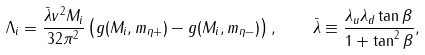<formula> <loc_0><loc_0><loc_500><loc_500>\Lambda _ { i } = \frac { \bar { \lambda } v ^ { 2 } M _ { i } } { 3 2 \pi ^ { 2 } } \left ( g ( M _ { i } , m _ { \eta + } ) - g ( M _ { i } , m _ { \eta - } ) \right ) , \quad \bar { \lambda } \equiv \frac { \lambda _ { u } \lambda _ { d } \tan \beta } { 1 + \tan ^ { 2 } \beta } ,</formula> 